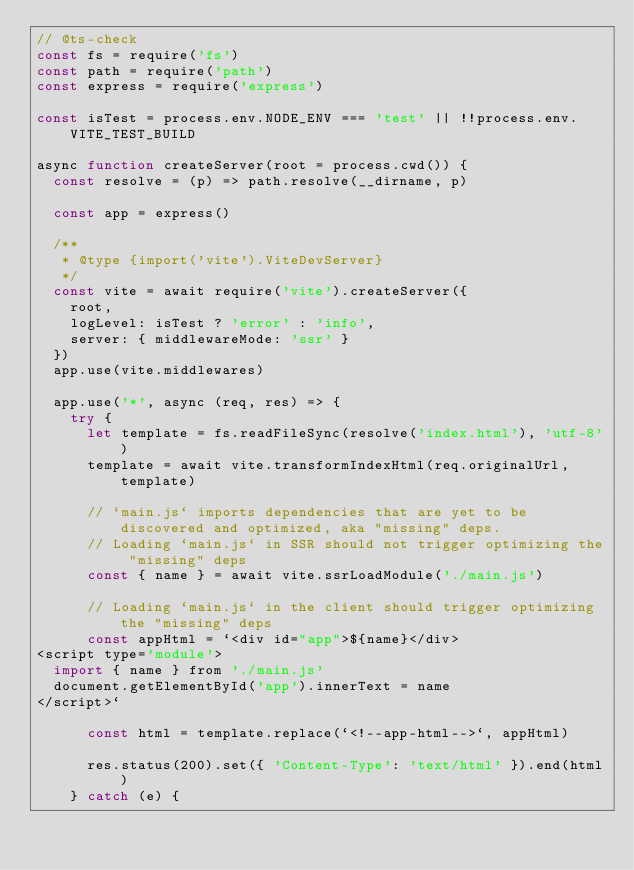Convert code to text. <code><loc_0><loc_0><loc_500><loc_500><_JavaScript_>// @ts-check
const fs = require('fs')
const path = require('path')
const express = require('express')

const isTest = process.env.NODE_ENV === 'test' || !!process.env.VITE_TEST_BUILD

async function createServer(root = process.cwd()) {
  const resolve = (p) => path.resolve(__dirname, p)

  const app = express()

  /**
   * @type {import('vite').ViteDevServer}
   */
  const vite = await require('vite').createServer({
    root,
    logLevel: isTest ? 'error' : 'info',
    server: { middlewareMode: 'ssr' }
  })
  app.use(vite.middlewares)

  app.use('*', async (req, res) => {
    try {
      let template = fs.readFileSync(resolve('index.html'), 'utf-8')
      template = await vite.transformIndexHtml(req.originalUrl, template)

      // `main.js` imports dependencies that are yet to be discovered and optimized, aka "missing" deps.
      // Loading `main.js` in SSR should not trigger optimizing the "missing" deps
      const { name } = await vite.ssrLoadModule('./main.js')

      // Loading `main.js` in the client should trigger optimizing the "missing" deps
      const appHtml = `<div id="app">${name}</div>
<script type='module'>
  import { name } from './main.js'
  document.getElementById('app').innerText = name
</script>`

      const html = template.replace(`<!--app-html-->`, appHtml)

      res.status(200).set({ 'Content-Type': 'text/html' }).end(html)
    } catch (e) {</code> 